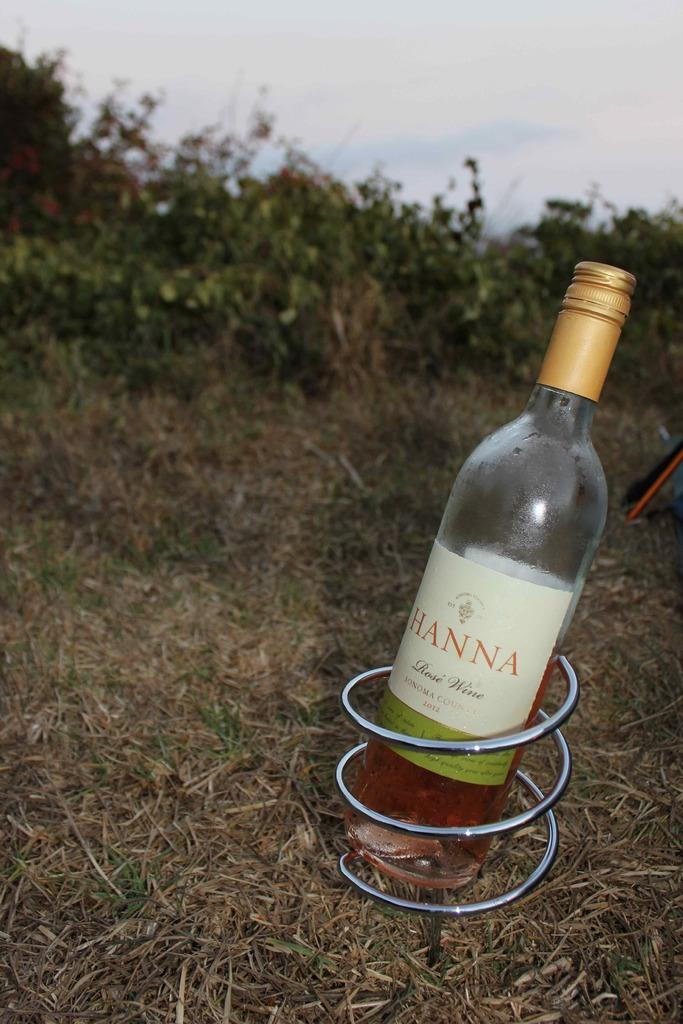Provide a one-sentence caption for the provided image. Bottle of Hanna rose wine sonoma county on some grass. 